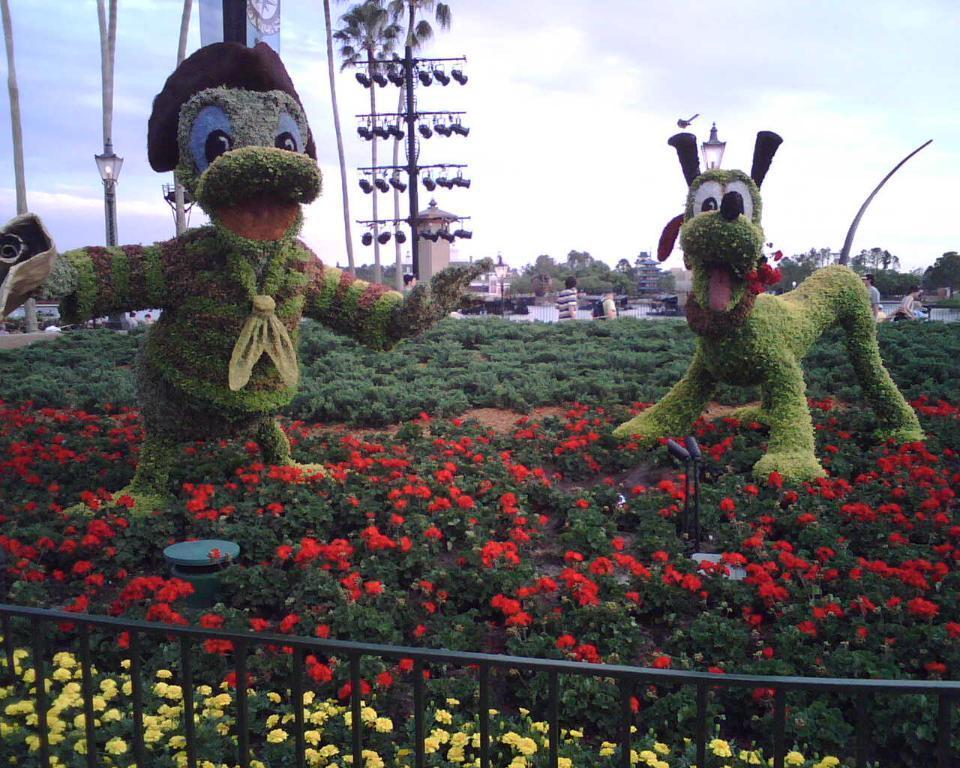Please provide a concise description of this image. In this picture we can see trees which are in animal shapes, here we can see plants with flowers on the ground and in the background we can see few people, trees, sky and some objects. 